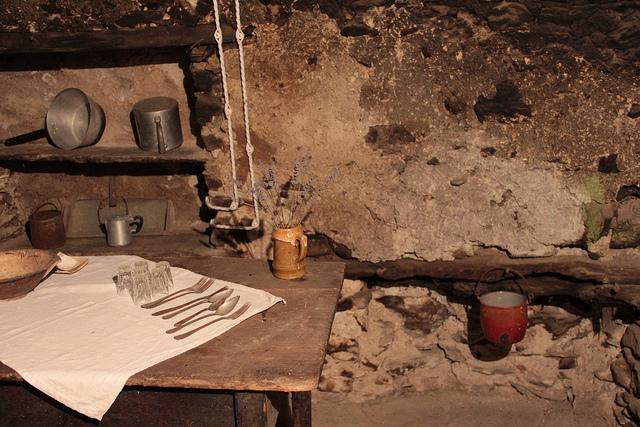Is this outdoors?
Quick response, please. No. What type utensils are laid out?
Be succinct. Forks. Is this a luxury apartment?
Concise answer only. No. 